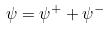<formula> <loc_0><loc_0><loc_500><loc_500>\psi = \psi ^ { + } + \psi ^ { - }</formula> 